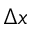<formula> <loc_0><loc_0><loc_500><loc_500>\Delta x</formula> 